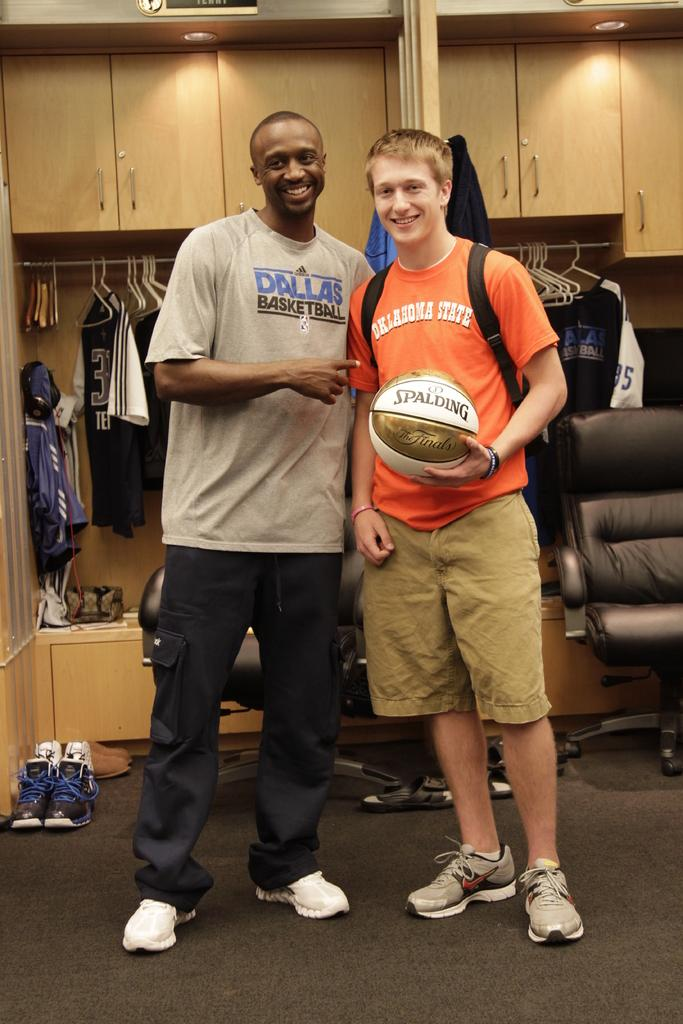<image>
Offer a succinct explanation of the picture presented. two men with sports t shirts on holding a spalding basketball 